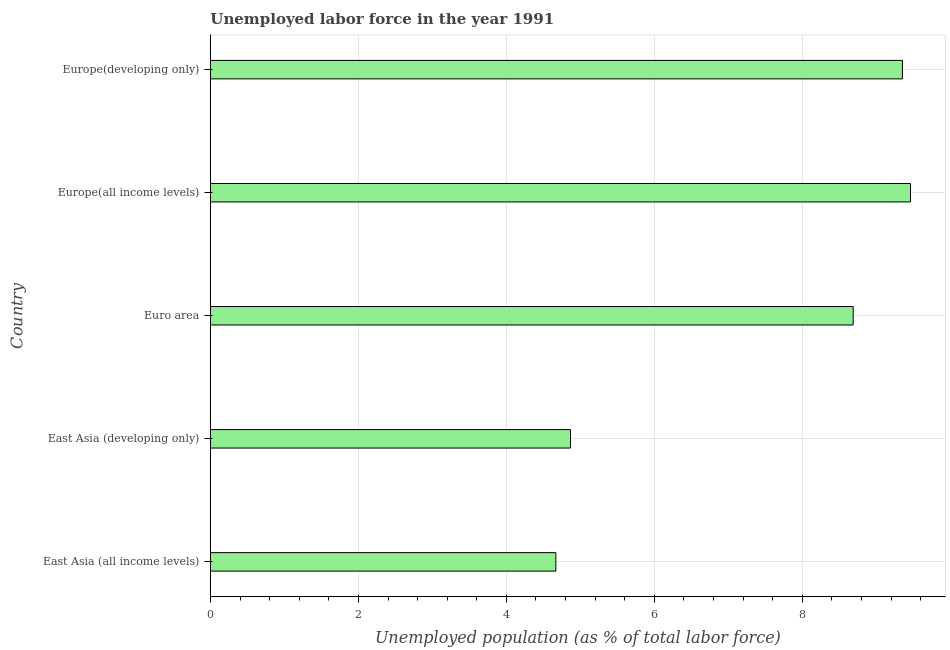Does the graph contain any zero values?
Make the answer very short. No. What is the title of the graph?
Make the answer very short. Unemployed labor force in the year 1991. What is the label or title of the X-axis?
Make the answer very short. Unemployed population (as % of total labor force). What is the label or title of the Y-axis?
Your response must be concise. Country. What is the total unemployed population in Europe(developing only)?
Provide a succinct answer. 9.35. Across all countries, what is the maximum total unemployed population?
Offer a terse response. 9.46. Across all countries, what is the minimum total unemployed population?
Offer a very short reply. 4.67. In which country was the total unemployed population maximum?
Offer a terse response. Europe(all income levels). In which country was the total unemployed population minimum?
Provide a short and direct response. East Asia (all income levels). What is the sum of the total unemployed population?
Provide a succinct answer. 37.04. What is the difference between the total unemployed population in East Asia (developing only) and Europe(all income levels)?
Offer a very short reply. -4.6. What is the average total unemployed population per country?
Provide a succinct answer. 7.41. What is the median total unemployed population?
Offer a very short reply. 8.69. What is the ratio of the total unemployed population in East Asia (all income levels) to that in East Asia (developing only)?
Provide a short and direct response. 0.96. Is the total unemployed population in Europe(all income levels) less than that in Europe(developing only)?
Ensure brevity in your answer.  No. Is the difference between the total unemployed population in Euro area and Europe(all income levels) greater than the difference between any two countries?
Your answer should be very brief. No. What is the difference between the highest and the second highest total unemployed population?
Make the answer very short. 0.11. Is the sum of the total unemployed population in East Asia (developing only) and Europe(developing only) greater than the maximum total unemployed population across all countries?
Your answer should be very brief. Yes. What is the difference between the highest and the lowest total unemployed population?
Give a very brief answer. 4.79. What is the difference between two consecutive major ticks on the X-axis?
Provide a short and direct response. 2. What is the Unemployed population (as % of total labor force) of East Asia (all income levels)?
Ensure brevity in your answer.  4.67. What is the Unemployed population (as % of total labor force) of East Asia (developing only)?
Your response must be concise. 4.87. What is the Unemployed population (as % of total labor force) of Euro area?
Your response must be concise. 8.69. What is the Unemployed population (as % of total labor force) of Europe(all income levels)?
Ensure brevity in your answer.  9.46. What is the Unemployed population (as % of total labor force) of Europe(developing only)?
Make the answer very short. 9.35. What is the difference between the Unemployed population (as % of total labor force) in East Asia (all income levels) and East Asia (developing only)?
Your answer should be compact. -0.2. What is the difference between the Unemployed population (as % of total labor force) in East Asia (all income levels) and Euro area?
Ensure brevity in your answer.  -4.02. What is the difference between the Unemployed population (as % of total labor force) in East Asia (all income levels) and Europe(all income levels)?
Make the answer very short. -4.79. What is the difference between the Unemployed population (as % of total labor force) in East Asia (all income levels) and Europe(developing only)?
Provide a short and direct response. -4.68. What is the difference between the Unemployed population (as % of total labor force) in East Asia (developing only) and Euro area?
Offer a very short reply. -3.82. What is the difference between the Unemployed population (as % of total labor force) in East Asia (developing only) and Europe(all income levels)?
Ensure brevity in your answer.  -4.6. What is the difference between the Unemployed population (as % of total labor force) in East Asia (developing only) and Europe(developing only)?
Keep it short and to the point. -4.49. What is the difference between the Unemployed population (as % of total labor force) in Euro area and Europe(all income levels)?
Provide a short and direct response. -0.77. What is the difference between the Unemployed population (as % of total labor force) in Euro area and Europe(developing only)?
Provide a succinct answer. -0.67. What is the difference between the Unemployed population (as % of total labor force) in Europe(all income levels) and Europe(developing only)?
Your answer should be very brief. 0.11. What is the ratio of the Unemployed population (as % of total labor force) in East Asia (all income levels) to that in Euro area?
Your answer should be compact. 0.54. What is the ratio of the Unemployed population (as % of total labor force) in East Asia (all income levels) to that in Europe(all income levels)?
Provide a short and direct response. 0.49. What is the ratio of the Unemployed population (as % of total labor force) in East Asia (all income levels) to that in Europe(developing only)?
Ensure brevity in your answer.  0.5. What is the ratio of the Unemployed population (as % of total labor force) in East Asia (developing only) to that in Euro area?
Provide a succinct answer. 0.56. What is the ratio of the Unemployed population (as % of total labor force) in East Asia (developing only) to that in Europe(all income levels)?
Your answer should be very brief. 0.51. What is the ratio of the Unemployed population (as % of total labor force) in East Asia (developing only) to that in Europe(developing only)?
Keep it short and to the point. 0.52. What is the ratio of the Unemployed population (as % of total labor force) in Euro area to that in Europe(all income levels)?
Ensure brevity in your answer.  0.92. What is the ratio of the Unemployed population (as % of total labor force) in Euro area to that in Europe(developing only)?
Provide a succinct answer. 0.93. 